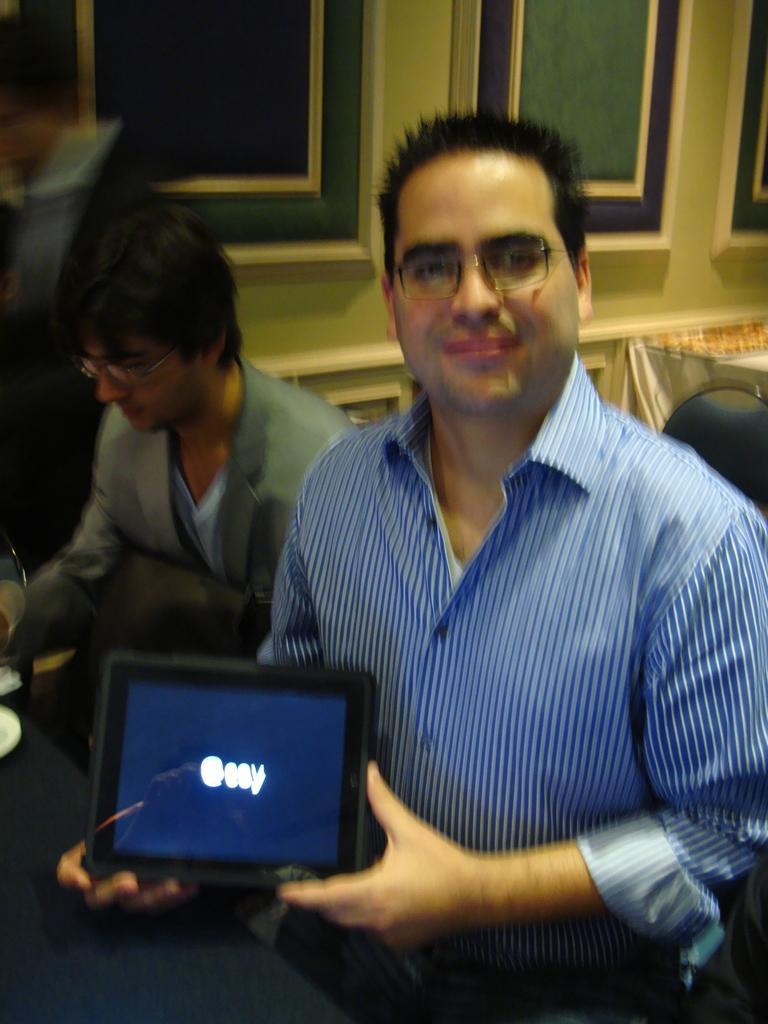In one or two sentences, can you explain what this image depicts? The man in front of the picture who is wearing the blue shirt and the spectacles is sitting on the chair. He is holding the tablet in his hands and he is smiling. Beside him, the man in the grey blazer is sitting on the chair. He is wearing the spectacles. In front of them, we see a table. In the background, we see a wall and something which look like the windows. This picture is blurred. 